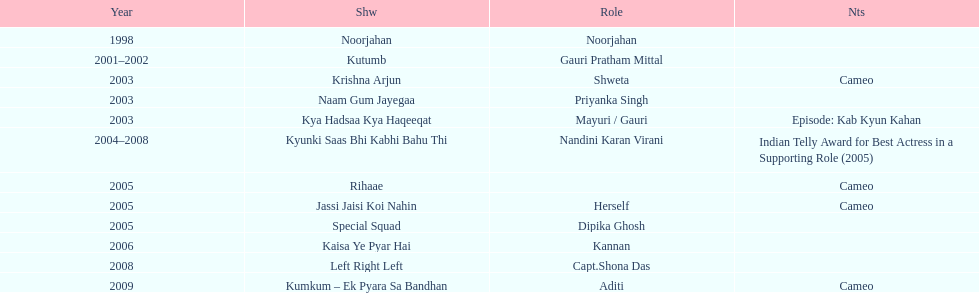In total, how many different tv series has gauri tejwani either starred or cameoed in? 11. 